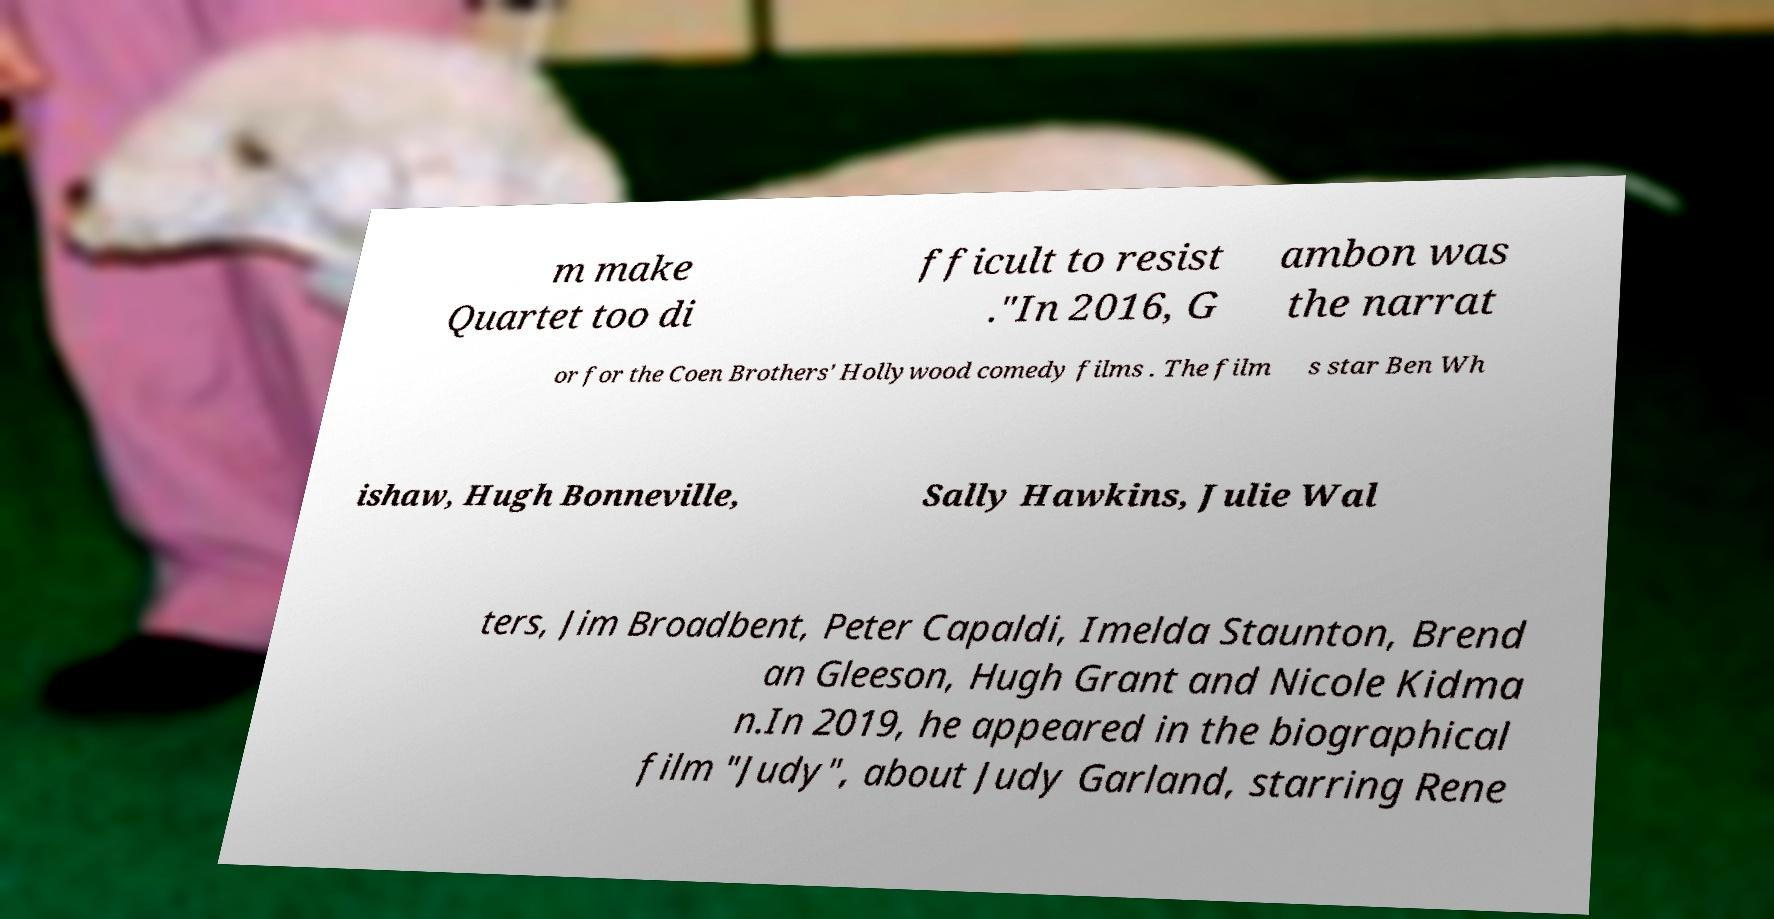Could you extract and type out the text from this image? m make Quartet too di fficult to resist ."In 2016, G ambon was the narrat or for the Coen Brothers' Hollywood comedy films . The film s star Ben Wh ishaw, Hugh Bonneville, Sally Hawkins, Julie Wal ters, Jim Broadbent, Peter Capaldi, Imelda Staunton, Brend an Gleeson, Hugh Grant and Nicole Kidma n.In 2019, he appeared in the biographical film "Judy", about Judy Garland, starring Rene 